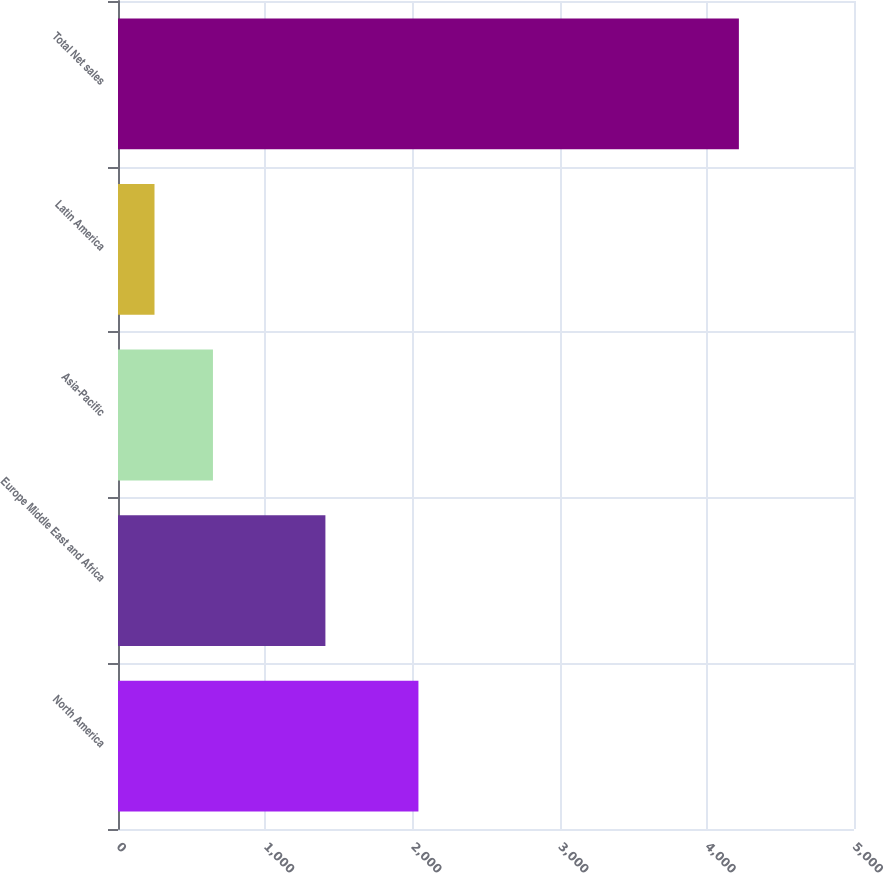Convert chart. <chart><loc_0><loc_0><loc_500><loc_500><bar_chart><fcel>North America<fcel>Europe Middle East and Africa<fcel>Asia-Pacific<fcel>Latin America<fcel>Total Net sales<nl><fcel>2041<fcel>1409<fcel>645<fcel>248<fcel>4218<nl></chart> 